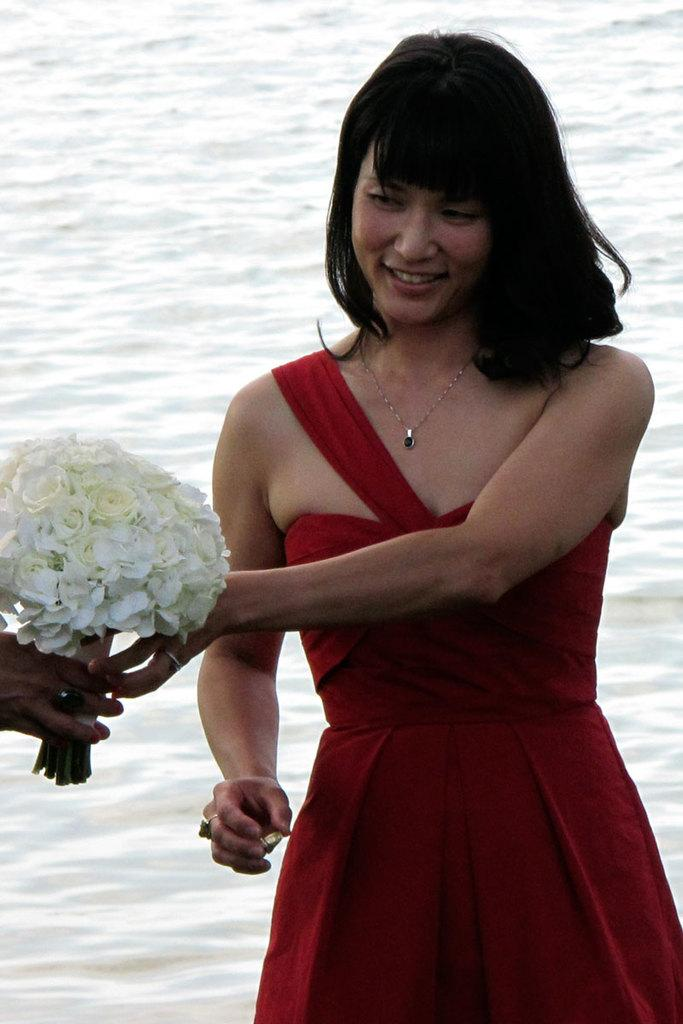Who is the main subject in the foreground of the image? There is a woman in the foreground of the image. What is the woman doing in the image? The woman is standing and smiling. What is the woman holding in the image? The woman is holding a flower bouquet. What can be seen in the background of the image? There is a beach in the background of the image. What is the purpose of the tank in the image? There is no tank present in the image. 